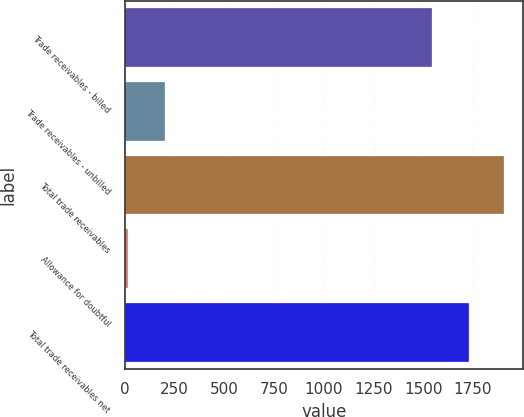<chart> <loc_0><loc_0><loc_500><loc_500><bar_chart><fcel>Trade receivables - billed<fcel>Trade receivables - unbilled<fcel>Total trade receivables<fcel>Allowance for doubtful<fcel>Total trade receivables net<nl><fcel>1546<fcel>201<fcel>1904.1<fcel>16<fcel>1731<nl></chart> 